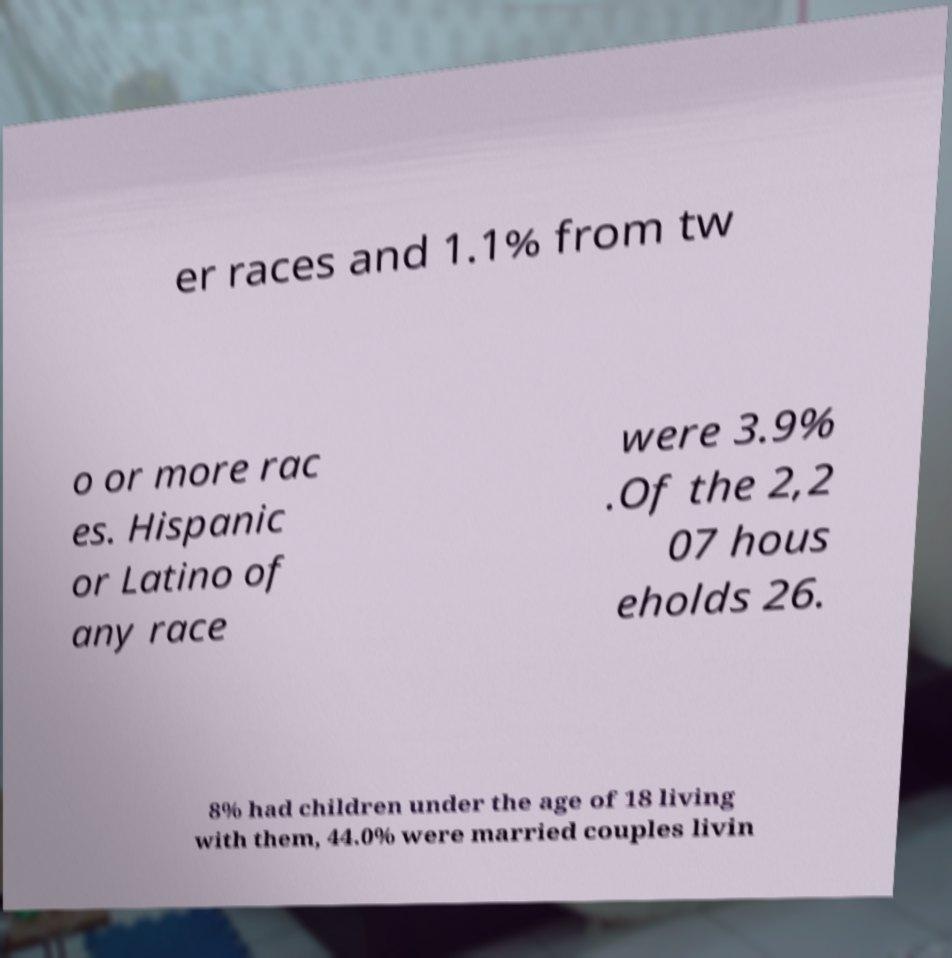Can you read and provide the text displayed in the image?This photo seems to have some interesting text. Can you extract and type it out for me? er races and 1.1% from tw o or more rac es. Hispanic or Latino of any race were 3.9% .Of the 2,2 07 hous eholds 26. 8% had children under the age of 18 living with them, 44.0% were married couples livin 